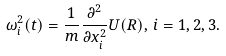<formula> <loc_0><loc_0><loc_500><loc_500>\omega _ { i } ^ { 2 } ( t ) = \frac { 1 } { m } \frac { \partial ^ { 2 } } { \partial x _ { i } ^ { 2 } } U ( R ) , \, i = 1 , 2 , 3 .</formula> 